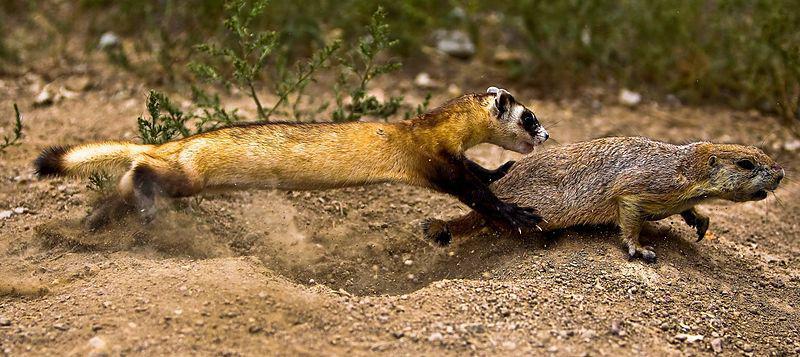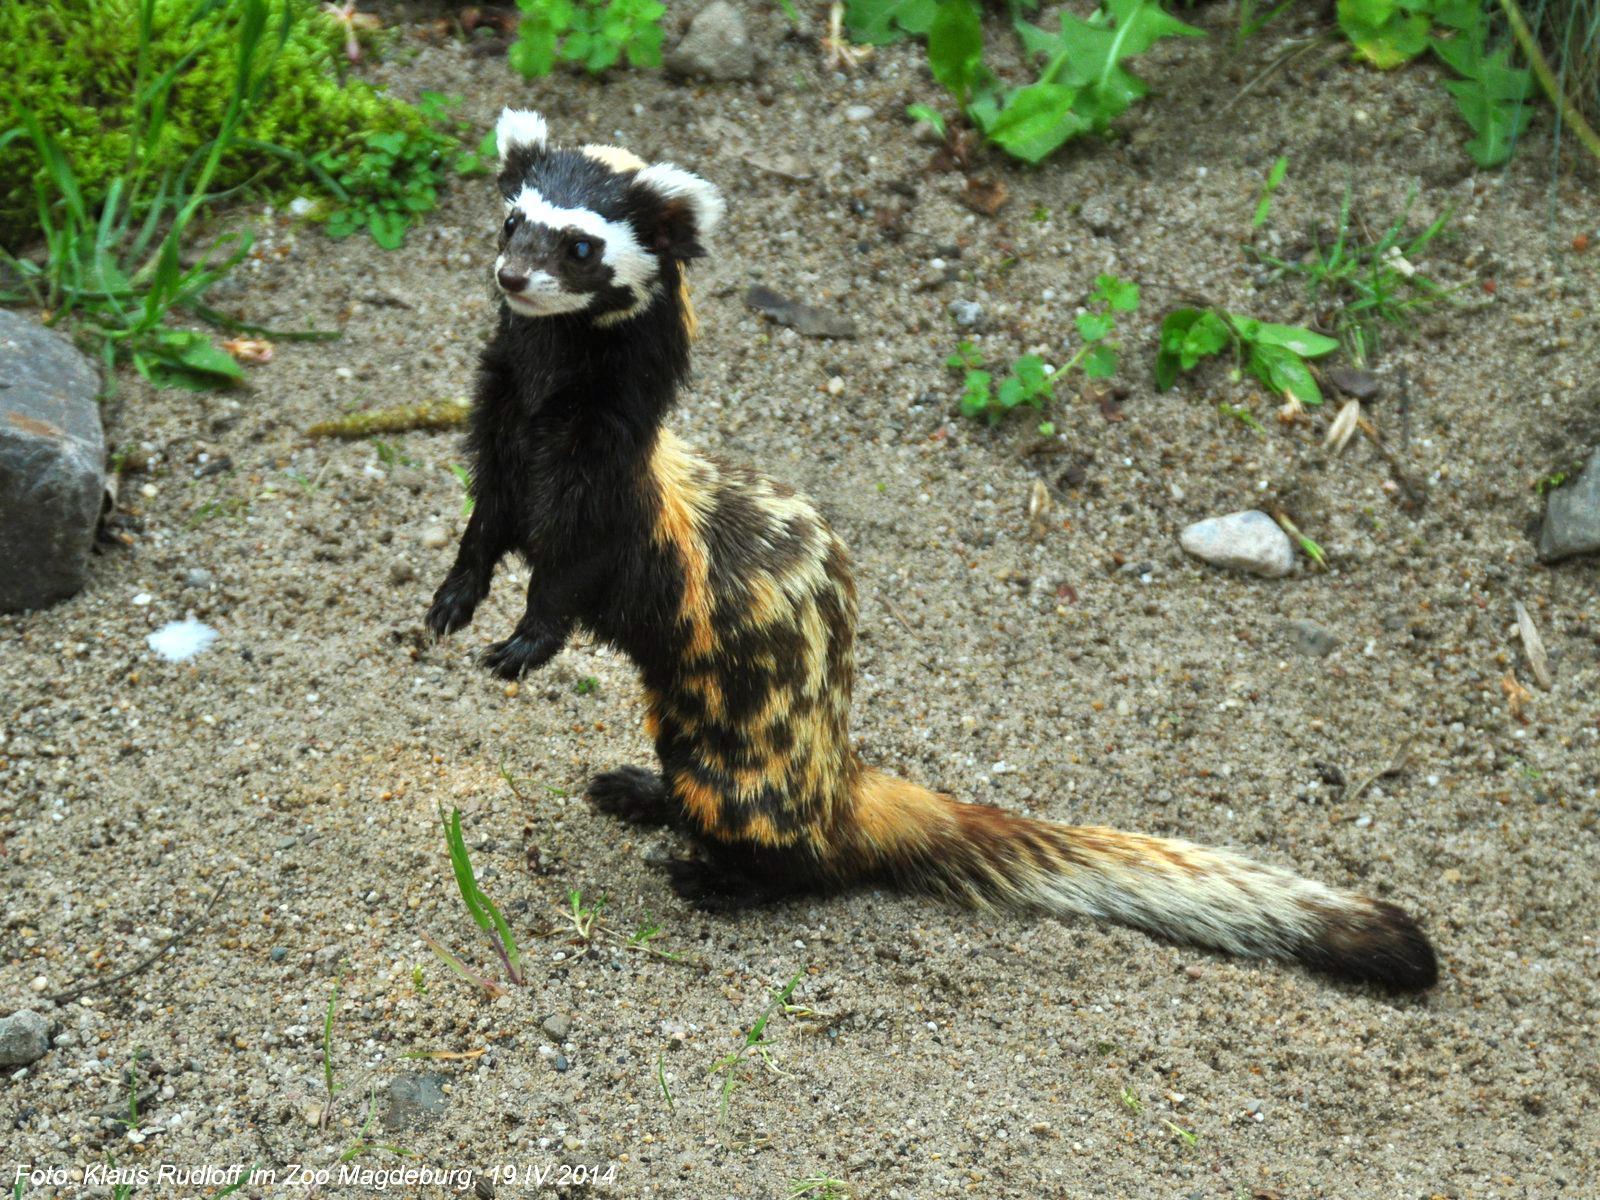The first image is the image on the left, the second image is the image on the right. Considering the images on both sides, is "One image shows a single ferret with its head raised and gazing leftward." valid? Answer yes or no. Yes. The first image is the image on the left, the second image is the image on the right. Analyze the images presented: Is the assertion "The right image contains exactly one ferret curled up on the floor." valid? Answer yes or no. No. 